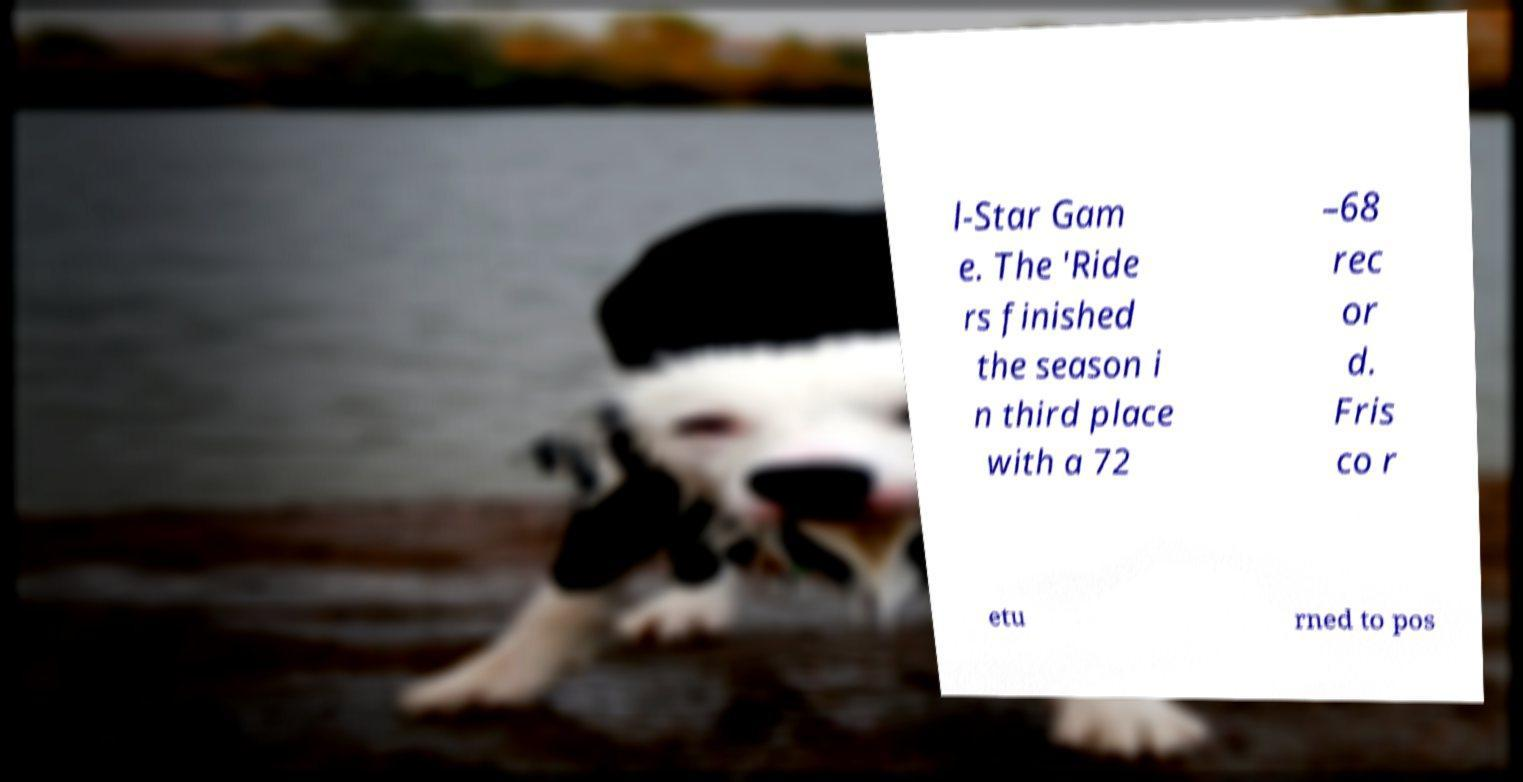For documentation purposes, I need the text within this image transcribed. Could you provide that? l-Star Gam e. The 'Ride rs finished the season i n third place with a 72 –68 rec or d. Fris co r etu rned to pos 